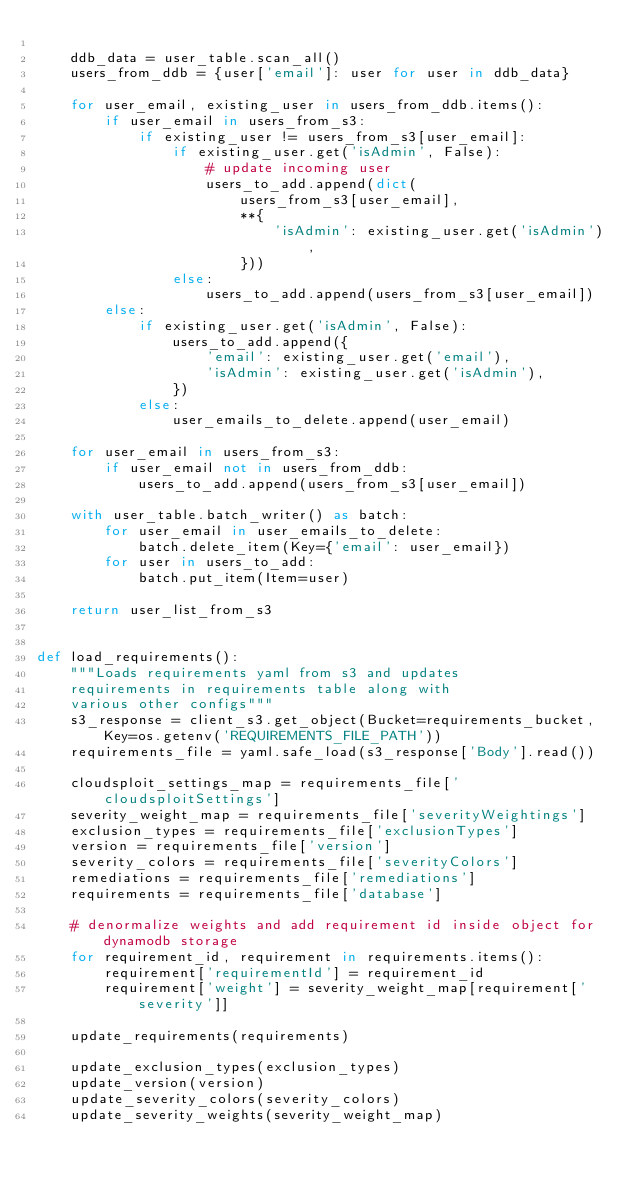Convert code to text. <code><loc_0><loc_0><loc_500><loc_500><_Python_>
    ddb_data = user_table.scan_all()
    users_from_ddb = {user['email']: user for user in ddb_data}

    for user_email, existing_user in users_from_ddb.items():
        if user_email in users_from_s3:
            if existing_user != users_from_s3[user_email]:
                if existing_user.get('isAdmin', False):
                    # update incoming user
                    users_to_add.append(dict(
                        users_from_s3[user_email],
                        **{
                            'isAdmin': existing_user.get('isAdmin'),
                        }))
                else:
                    users_to_add.append(users_from_s3[user_email])
        else:
            if existing_user.get('isAdmin', False):
                users_to_add.append({
                    'email': existing_user.get('email'),
                    'isAdmin': existing_user.get('isAdmin'),
                })
            else:
                user_emails_to_delete.append(user_email)

    for user_email in users_from_s3:
        if user_email not in users_from_ddb:
            users_to_add.append(users_from_s3[user_email])

    with user_table.batch_writer() as batch:
        for user_email in user_emails_to_delete:
            batch.delete_item(Key={'email': user_email})
        for user in users_to_add:
            batch.put_item(Item=user)

    return user_list_from_s3


def load_requirements():
    """Loads requirements yaml from s3 and updates
    requirements in requirements table along with
    various other configs"""
    s3_response = client_s3.get_object(Bucket=requirements_bucket, Key=os.getenv('REQUIREMENTS_FILE_PATH'))
    requirements_file = yaml.safe_load(s3_response['Body'].read())

    cloudsploit_settings_map = requirements_file['cloudsploitSettings']
    severity_weight_map = requirements_file['severityWeightings']
    exclusion_types = requirements_file['exclusionTypes']
    version = requirements_file['version']
    severity_colors = requirements_file['severityColors']
    remediations = requirements_file['remediations']
    requirements = requirements_file['database']

    # denormalize weights and add requirement id inside object for dynamodb storage
    for requirement_id, requirement in requirements.items():
        requirement['requirementId'] = requirement_id
        requirement['weight'] = severity_weight_map[requirement['severity']]

    update_requirements(requirements)

    update_exclusion_types(exclusion_types)
    update_version(version)
    update_severity_colors(severity_colors)
    update_severity_weights(severity_weight_map)</code> 